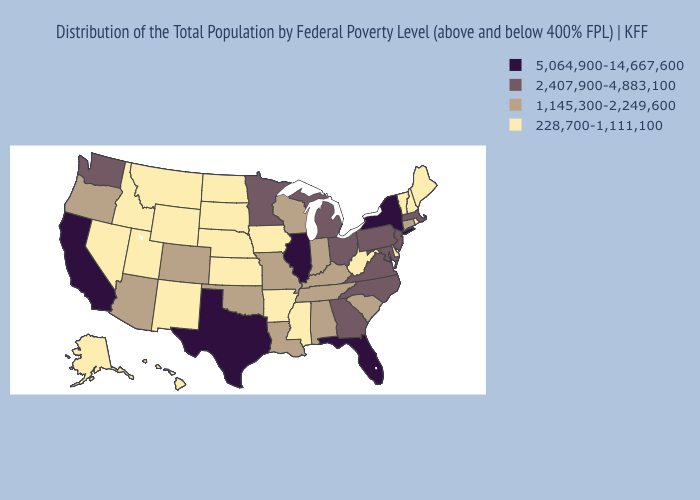Among the states that border Wyoming , which have the highest value?
Give a very brief answer. Colorado. Does Vermont have the lowest value in the USA?
Write a very short answer. Yes. What is the lowest value in the MidWest?
Quick response, please. 228,700-1,111,100. What is the value of Ohio?
Keep it brief. 2,407,900-4,883,100. Does Minnesota have a higher value than Oregon?
Short answer required. Yes. Does Colorado have a lower value than Maryland?
Quick response, please. Yes. Does Colorado have the highest value in the USA?
Short answer required. No. What is the value of Washington?
Short answer required. 2,407,900-4,883,100. Name the states that have a value in the range 228,700-1,111,100?
Write a very short answer. Alaska, Arkansas, Delaware, Hawaii, Idaho, Iowa, Kansas, Maine, Mississippi, Montana, Nebraska, Nevada, New Hampshire, New Mexico, North Dakota, Rhode Island, South Dakota, Utah, Vermont, West Virginia, Wyoming. What is the highest value in the West ?
Write a very short answer. 5,064,900-14,667,600. Does the first symbol in the legend represent the smallest category?
Write a very short answer. No. Among the states that border Maine , which have the highest value?
Give a very brief answer. New Hampshire. Name the states that have a value in the range 1,145,300-2,249,600?
Keep it brief. Alabama, Arizona, Colorado, Connecticut, Indiana, Kentucky, Louisiana, Missouri, Oklahoma, Oregon, South Carolina, Tennessee, Wisconsin. Does Indiana have the highest value in the MidWest?
Concise answer only. No. What is the value of Alaska?
Concise answer only. 228,700-1,111,100. 